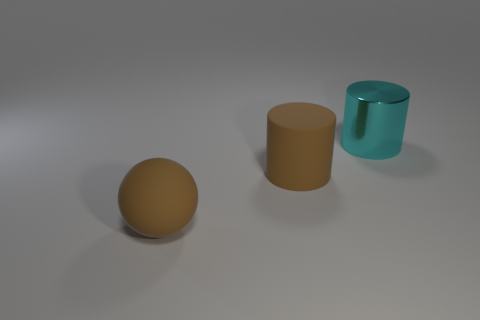Add 2 metal things. How many objects exist? 5 Subtract all balls. How many objects are left? 2 Add 1 large matte balls. How many large matte balls are left? 2 Add 2 tiny yellow balls. How many tiny yellow balls exist? 2 Subtract 1 brown balls. How many objects are left? 2 Subtract all large brown cylinders. Subtract all small green cylinders. How many objects are left? 2 